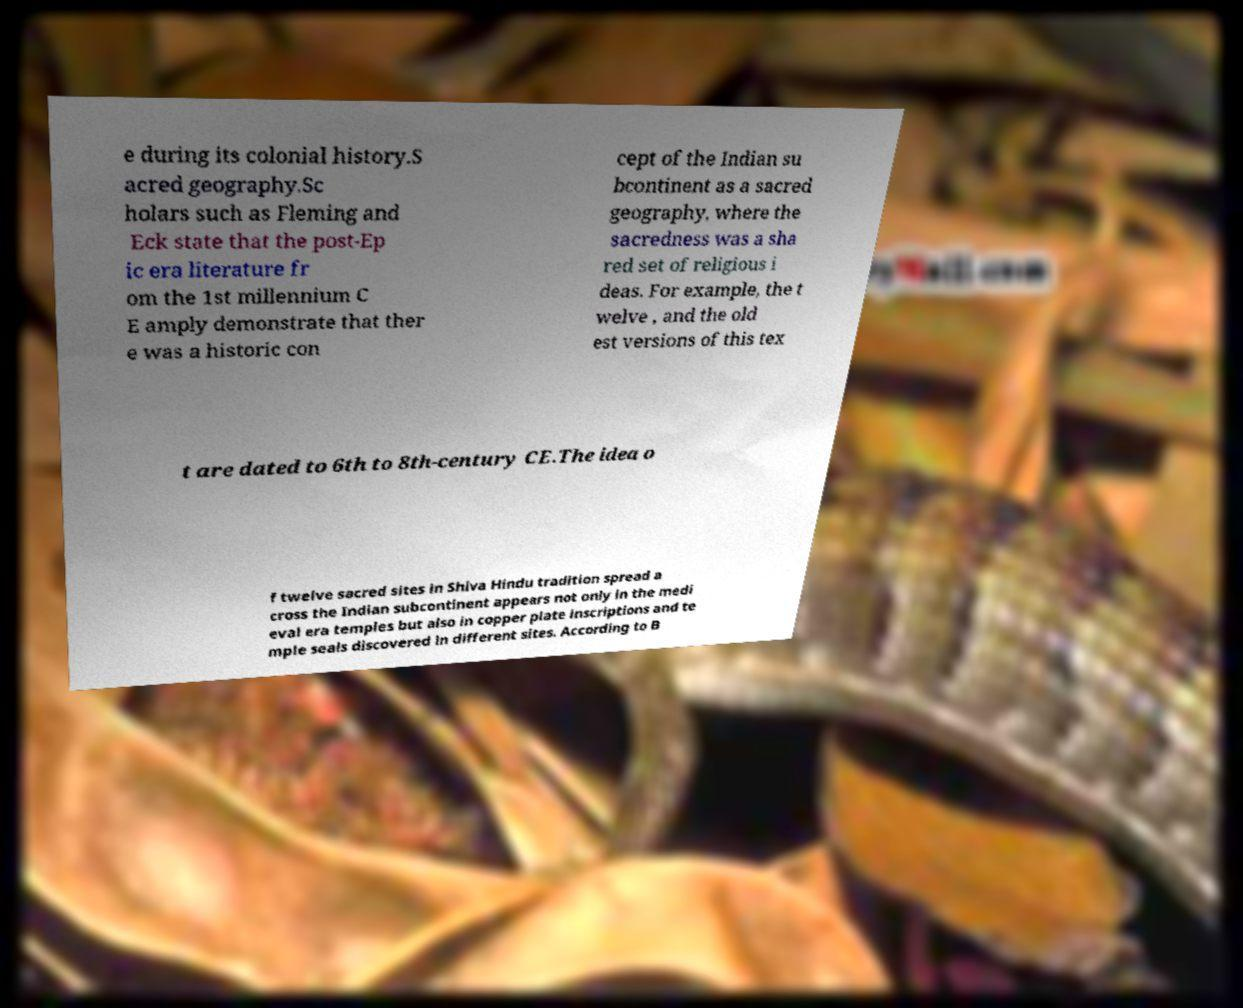What messages or text are displayed in this image? I need them in a readable, typed format. e during its colonial history.S acred geography.Sc holars such as Fleming and Eck state that the post-Ep ic era literature fr om the 1st millennium C E amply demonstrate that ther e was a historic con cept of the Indian su bcontinent as a sacred geography, where the sacredness was a sha red set of religious i deas. For example, the t welve , and the old est versions of this tex t are dated to 6th to 8th-century CE.The idea o f twelve sacred sites in Shiva Hindu tradition spread a cross the Indian subcontinent appears not only in the medi eval era temples but also in copper plate inscriptions and te mple seals discovered in different sites. According to B 